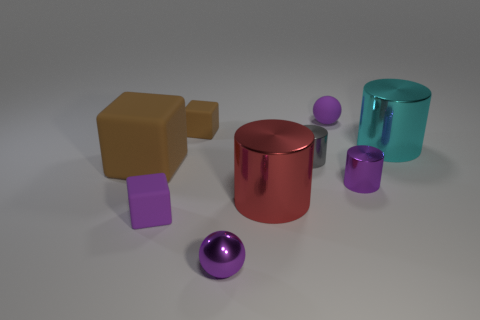Is there a sense of movement or stillness in the image? The composition conveys a sense of stillness. There are no indications of movement or dynamic action; the objects are stationary. The positioning and shadows of the objects suggest a static arrangement carefully placed within the scene. 